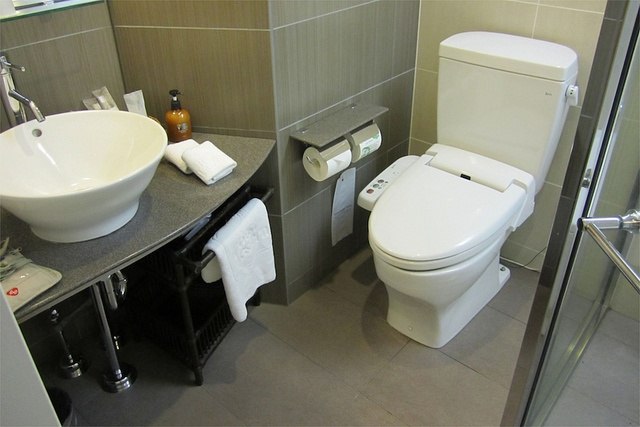Describe the objects in this image and their specific colors. I can see toilet in lightgray, darkgray, and gray tones, sink in lightgray, beige, darkgray, and gray tones, and bottle in lightgray, olive, maroon, and black tones in this image. 